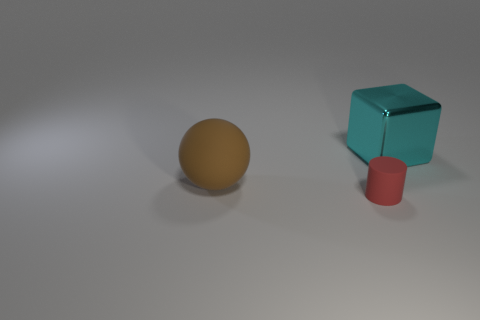There is a object that is both behind the tiny matte object and on the left side of the large cyan shiny thing; what shape is it?
Your response must be concise. Sphere. How many things are big things that are on the left side of the tiny cylinder or things to the right of the big brown thing?
Provide a short and direct response. 3. What shape is the cyan object?
Your answer should be compact. Cube. What number of small cylinders have the same material as the brown thing?
Offer a terse response. 1. What is the color of the sphere?
Provide a succinct answer. Brown. The thing that is the same size as the brown rubber ball is what color?
Offer a terse response. Cyan. Is there a small cylinder that has the same color as the shiny block?
Provide a succinct answer. No. There is a big thing to the left of the red cylinder; is it the same shape as the thing to the right of the tiny red rubber cylinder?
Your answer should be very brief. No. How many other objects are there of the same size as the cyan metal block?
Provide a succinct answer. 1. There is a large rubber thing; does it have the same color as the big object that is behind the brown thing?
Provide a succinct answer. No. 